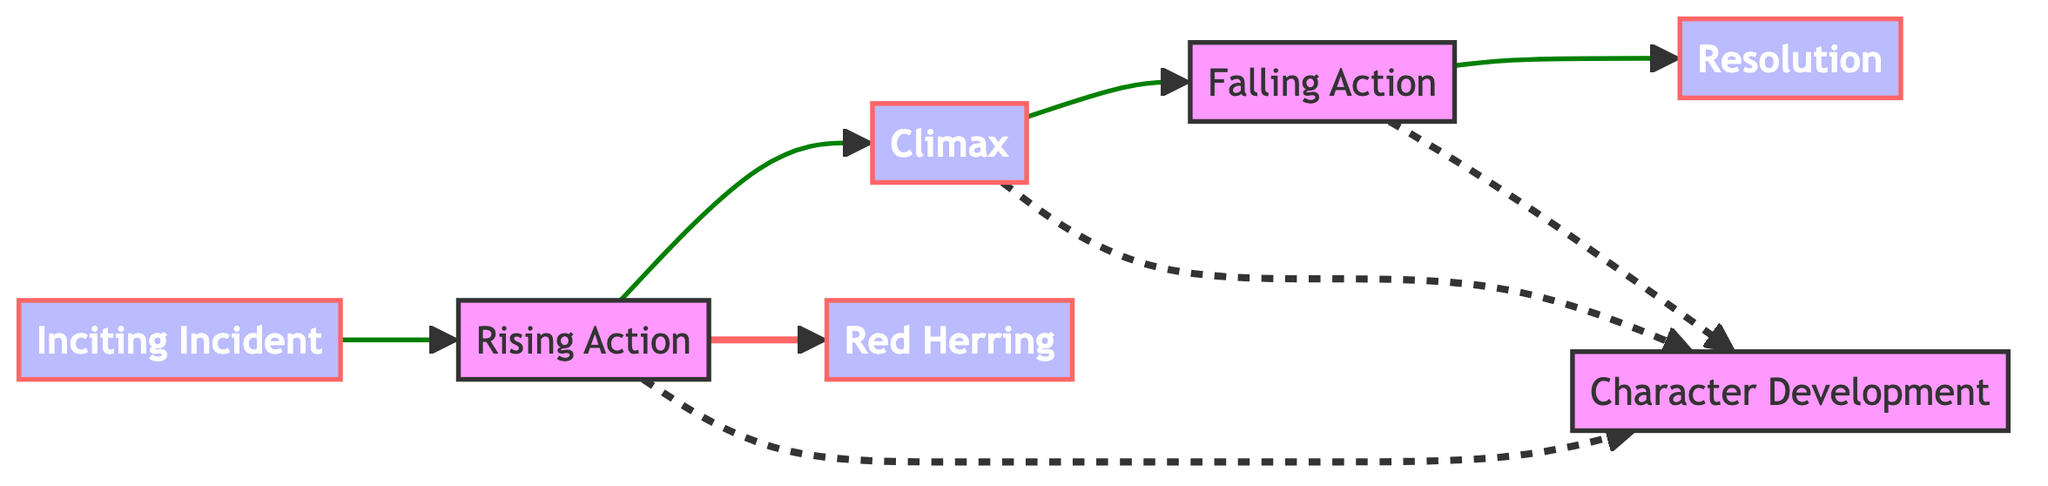What is the terminal node in the diagram? The terminal node is the last node in the directed graph, which is "Resolution." It represents the conclusion of the plot, where conflicts are resolved. By examining the edges, "Resolution" is the only node that does not have any outgoing edges, indicating it is an endpoint of the narrative flow.
Answer: Resolution How many nodes are there in total? Counting the nodes listed in the diagram, we find a total of 7 distinct elements: "Inciting Incident," "Rising Action," "Climax," "Falling Action," "Resolution," "Red Herring," and "Character Development." Therefore, the total number of nodes is 7.
Answer: 7 What relationship exists between "Rising Action" and "Climax"? In the directed graph, there is a direct edge from "Rising Action" to "Climax," indicating that the events and complications introduced in the Rising Action lead directly to the Climax, which is the turning point of the film. This directional relationship is indicated visually by the arrow pointing from "Rising Action" to "Climax."
Answer: Leads to Which nodes directly connect to "Falling Action"? Observing the diagram, "Falling Action" is connected from "Climax" and leads directly to "Resolution." It also connects to "Character Development," which means it has a total of three connections: one incoming from "Climax" and two outgoing to "Resolution" and "Character Development."
Answer: Climax, Resolution, Character Development What is the purpose of the "Red Herring" node? In the context of the diagram, "Red Herring" serves as a distraction or misleading clue that occurs during the "Rising Action." It is used strategically to mislead both the audience and the characters, thereby increasing tension and complexity in the narrative structure. The edge from "Rising Action" to "Red Herring" indicates that it is introduced at this stage.
Answer: Misleading clue How many edges are outgoing from "Rising Action"? Upon reviewing the connections from "Rising Action," we see it directs toward three nodes: "Climax," "Red Herring," and "Character Development." Thus, it has three outgoing edges connecting it to subsequent plot elements.
Answer: 3 What type of plot development is depicted at the "Climax" node? The "Climax" node represents the turning point of the film, where the main conflict reaches its highest intensity. This is where all the suspense builds, and crucial decisions are made, impacting the unfolding of the narrative. The position of "Climax" in the flow indicates its significance in turning the plot direction.
Answer: Turning point What do the dashed lines indicate in the diagram? The dashed lines in the diagram represent the connections to "Character Development" from "Rising Action," "Falling Action," and "Climax." These connections may imply that character growth is an inherent aspect throughout these phases, influencing how the plot evolves and resolves. The use of dashed lines can denote a different type of relationship as compared to solid connections.
Answer: Connections to Character Development 